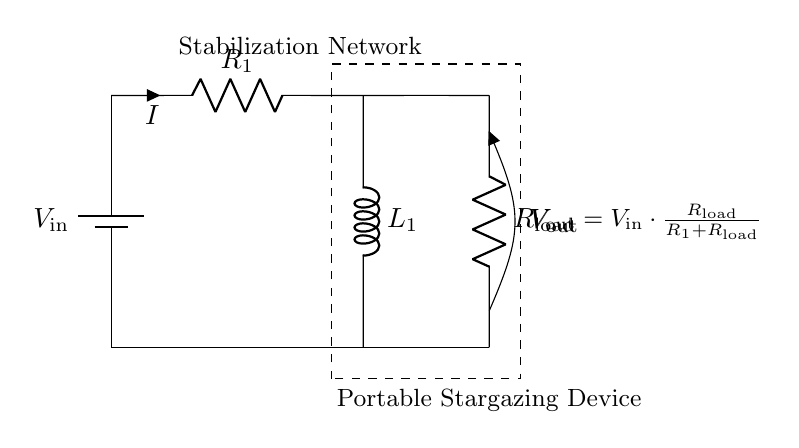What is the input voltage of the circuit? The circuit indicates a battery labeled with \( V_\text{in} \) as the input voltage.
Answer: V_in What component is used for stabilization in this circuit? The circuit shows a resistor and inductor placed together to form the stabilization network, labeled as \( R_1 \) and \( L_1 \).
Answer: Resistor-Inductor What is the load resistance labeled as? In the circuit, the resistance is indicated as \( R_\text{load} \), specifying the load in the system.
Answer: R_load What is the relationship between input and output voltage? The equation shown in the circuit diagram indicates that the output voltage \( V_\text{out} \) is calculated using the formula \( V_\text{out} = V_\text{in} \cdot \frac{R_\text{load}}{R_1 + R_\text{load}} \), which describes the voltage division in the circuit.
Answer: V_out = V_in * (R_load / (R_1 + R_load)) How does an increase in load resistance affect output voltage? An increase in \( R_\text{load} \) results in a higher fraction of \( V_\text{in} \) reaching \( V_\text{out} \) since it increases the voltage divider's ratio. Thus, \( V_\text{out} \) increases with higher \( R_\text{load} \).
Answer: Output voltage increases What is the purpose of the inductor in this circuit? The inductor \( L_1 \) provides energy storage and smoothing in the circuit, which helps in stabilizing the output voltage by reducing ripple and transient response due to load changes.
Answer: Energy storage and smoothing 